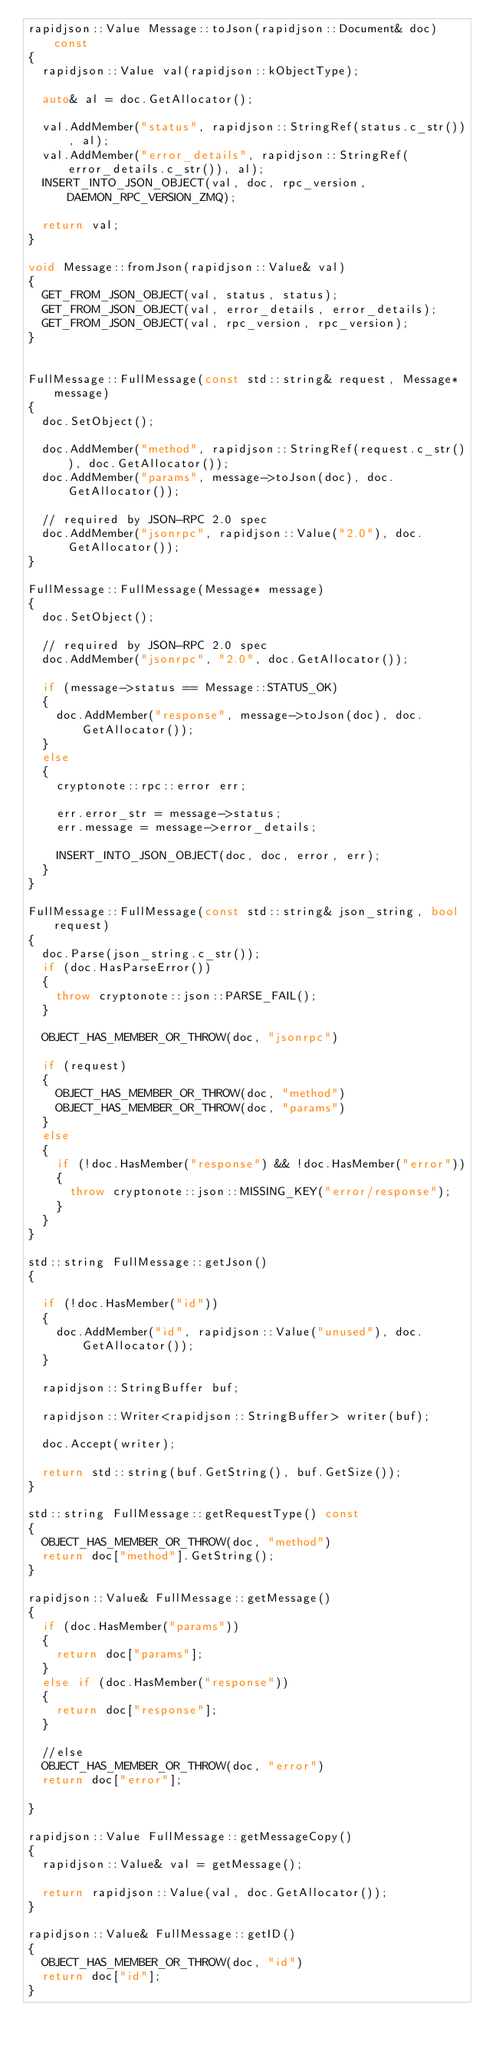Convert code to text. <code><loc_0><loc_0><loc_500><loc_500><_C++_>rapidjson::Value Message::toJson(rapidjson::Document& doc) const
{
  rapidjson::Value val(rapidjson::kObjectType);

  auto& al = doc.GetAllocator();

  val.AddMember("status", rapidjson::StringRef(status.c_str()), al);
  val.AddMember("error_details", rapidjson::StringRef(error_details.c_str()), al);
  INSERT_INTO_JSON_OBJECT(val, doc, rpc_version, DAEMON_RPC_VERSION_ZMQ);

  return val;
}

void Message::fromJson(rapidjson::Value& val)
{
  GET_FROM_JSON_OBJECT(val, status, status);
  GET_FROM_JSON_OBJECT(val, error_details, error_details);
  GET_FROM_JSON_OBJECT(val, rpc_version, rpc_version);
}


FullMessage::FullMessage(const std::string& request, Message* message)
{
  doc.SetObject();

  doc.AddMember("method", rapidjson::StringRef(request.c_str()), doc.GetAllocator());
  doc.AddMember("params", message->toJson(doc), doc.GetAllocator());

  // required by JSON-RPC 2.0 spec
  doc.AddMember("jsonrpc", rapidjson::Value("2.0"), doc.GetAllocator());
}

FullMessage::FullMessage(Message* message)
{
  doc.SetObject();

  // required by JSON-RPC 2.0 spec
  doc.AddMember("jsonrpc", "2.0", doc.GetAllocator());

  if (message->status == Message::STATUS_OK)
  {
    doc.AddMember("response", message->toJson(doc), doc.GetAllocator());
  }
  else
  {
    cryptonote::rpc::error err;

    err.error_str = message->status;
    err.message = message->error_details;

    INSERT_INTO_JSON_OBJECT(doc, doc, error, err);
  }
}

FullMessage::FullMessage(const std::string& json_string, bool request)
{
  doc.Parse(json_string.c_str());
  if (doc.HasParseError())
  {
    throw cryptonote::json::PARSE_FAIL();
  }

  OBJECT_HAS_MEMBER_OR_THROW(doc, "jsonrpc")

  if (request)
  {
    OBJECT_HAS_MEMBER_OR_THROW(doc, "method")
    OBJECT_HAS_MEMBER_OR_THROW(doc, "params")
  }
  else
  {
    if (!doc.HasMember("response") && !doc.HasMember("error"))
    {
      throw cryptonote::json::MISSING_KEY("error/response");
    }
  }
}

std::string FullMessage::getJson()
{

  if (!doc.HasMember("id"))
  {
    doc.AddMember("id", rapidjson::Value("unused"), doc.GetAllocator());
  }

  rapidjson::StringBuffer buf;

  rapidjson::Writer<rapidjson::StringBuffer> writer(buf);

  doc.Accept(writer);

  return std::string(buf.GetString(), buf.GetSize());
}

std::string FullMessage::getRequestType() const
{
  OBJECT_HAS_MEMBER_OR_THROW(doc, "method")
  return doc["method"].GetString();
}

rapidjson::Value& FullMessage::getMessage()
{
  if (doc.HasMember("params"))
  {
    return doc["params"];
  }
  else if (doc.HasMember("response"))
  {
    return doc["response"];
  }

  //else
  OBJECT_HAS_MEMBER_OR_THROW(doc, "error")
  return doc["error"];

}

rapidjson::Value FullMessage::getMessageCopy()
{
  rapidjson::Value& val = getMessage();

  return rapidjson::Value(val, doc.GetAllocator());
}

rapidjson::Value& FullMessage::getID()
{
  OBJECT_HAS_MEMBER_OR_THROW(doc, "id")
  return doc["id"];
}
</code> 